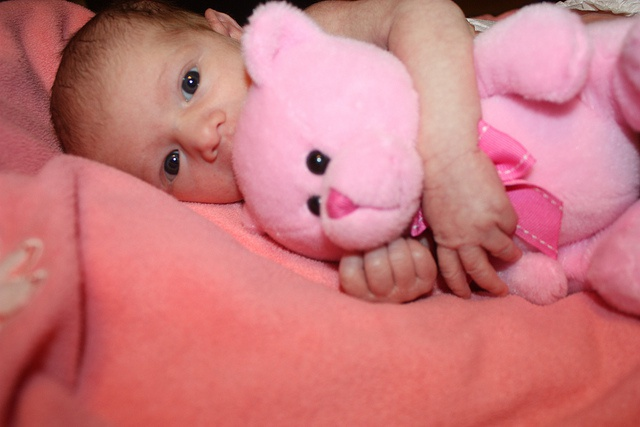Describe the objects in this image and their specific colors. I can see bed in black, salmon, and brown tones, teddy bear in black, pink, lightpink, and salmon tones, and people in black, lightpink, brown, maroon, and salmon tones in this image. 